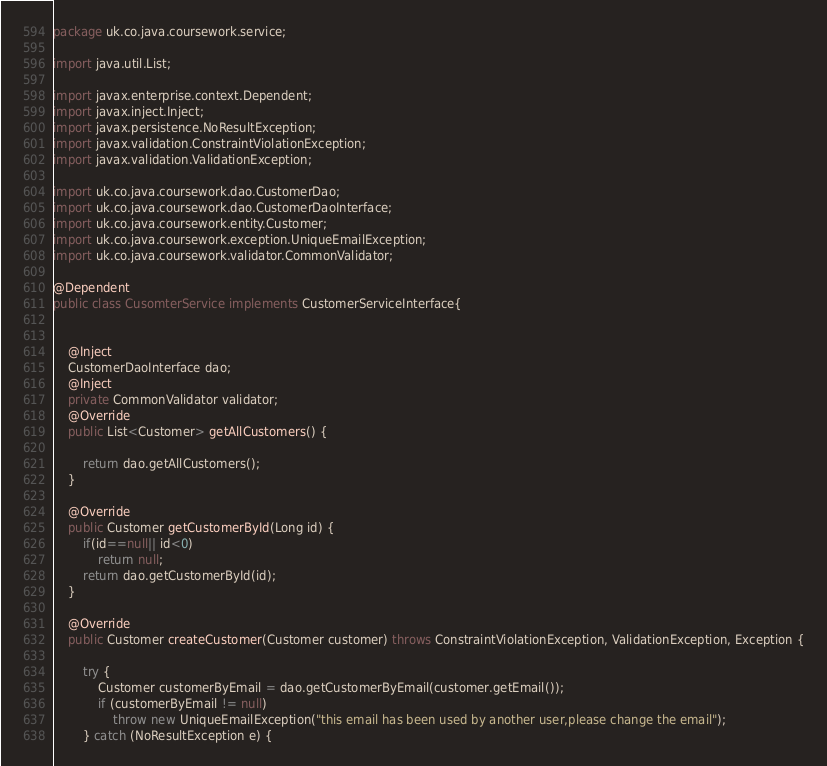Convert code to text. <code><loc_0><loc_0><loc_500><loc_500><_Java_>package uk.co.java.coursework.service;

import java.util.List;

import javax.enterprise.context.Dependent;
import javax.inject.Inject;
import javax.persistence.NoResultException;
import javax.validation.ConstraintViolationException;
import javax.validation.ValidationException;

import uk.co.java.coursework.dao.CustomerDao;
import uk.co.java.coursework.dao.CustomerDaoInterface;
import uk.co.java.coursework.entity.Customer;
import uk.co.java.coursework.exception.UniqueEmailException;
import uk.co.java.coursework.validator.CommonValidator;

@Dependent
public class CusomterService implements CustomerServiceInterface{

	
	@Inject
	CustomerDaoInterface dao;
	@Inject
	private CommonValidator validator;
	@Override
	public List<Customer> getAllCustomers() {
		
		return dao.getAllCustomers();
	}

	@Override
	public Customer getCustomerById(Long id) {
		if(id==null|| id<0)
			return null;
		return dao.getCustomerById(id);
	}

	@Override
	public Customer createCustomer(Customer customer) throws ConstraintViolationException, ValidationException, Exception {
				
		try {
			Customer customerByEmail = dao.getCustomerByEmail(customer.getEmail());
			if (customerByEmail != null)
				throw new UniqueEmailException("this email has been used by another user,please change the email");
		} catch (NoResultException e) {</code> 